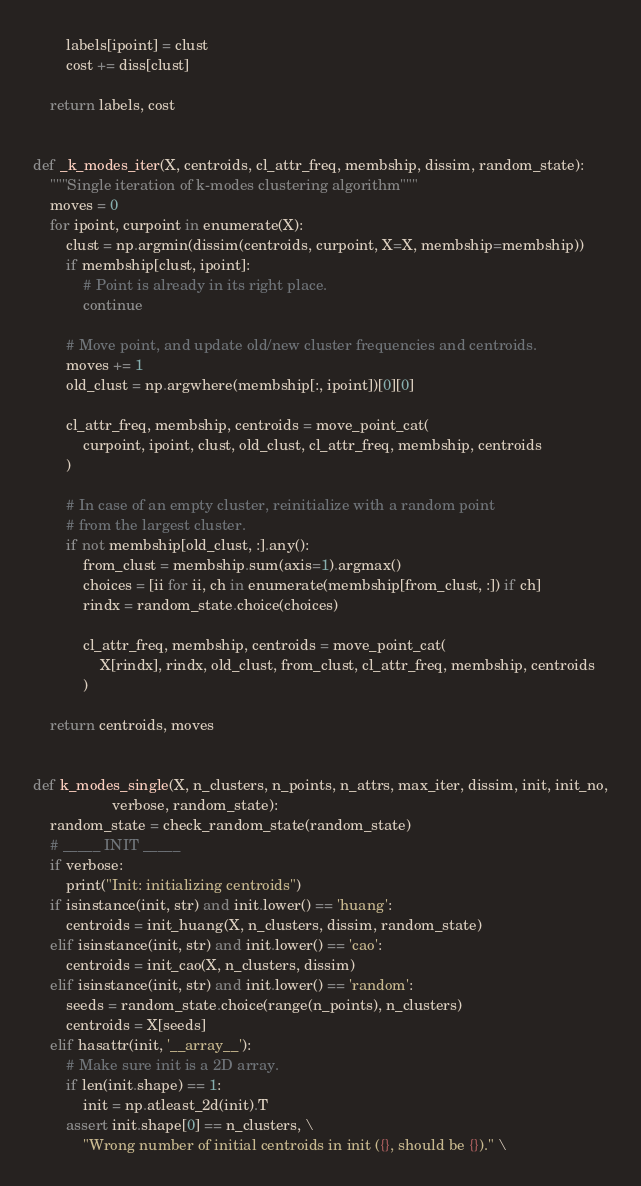<code> <loc_0><loc_0><loc_500><loc_500><_Python_>        labels[ipoint] = clust
        cost += diss[clust]

    return labels, cost


def _k_modes_iter(X, centroids, cl_attr_freq, membship, dissim, random_state):
    """Single iteration of k-modes clustering algorithm"""
    moves = 0
    for ipoint, curpoint in enumerate(X):
        clust = np.argmin(dissim(centroids, curpoint, X=X, membship=membship))
        if membship[clust, ipoint]:
            # Point is already in its right place.
            continue

        # Move point, and update old/new cluster frequencies and centroids.
        moves += 1
        old_clust = np.argwhere(membship[:, ipoint])[0][0]

        cl_attr_freq, membship, centroids = move_point_cat(
            curpoint, ipoint, clust, old_clust, cl_attr_freq, membship, centroids
        )

        # In case of an empty cluster, reinitialize with a random point
        # from the largest cluster.
        if not membship[old_clust, :].any():
            from_clust = membship.sum(axis=1).argmax()
            choices = [ii for ii, ch in enumerate(membship[from_clust, :]) if ch]
            rindx = random_state.choice(choices)

            cl_attr_freq, membship, centroids = move_point_cat(
                X[rindx], rindx, old_clust, from_clust, cl_attr_freq, membship, centroids
            )

    return centroids, moves


def k_modes_single(X, n_clusters, n_points, n_attrs, max_iter, dissim, init, init_no,
                   verbose, random_state):
    random_state = check_random_state(random_state)
    # _____ INIT _____
    if verbose:
        print("Init: initializing centroids")
    if isinstance(init, str) and init.lower() == 'huang':
        centroids = init_huang(X, n_clusters, dissim, random_state)
    elif isinstance(init, str) and init.lower() == 'cao':
        centroids = init_cao(X, n_clusters, dissim)
    elif isinstance(init, str) and init.lower() == 'random':
        seeds = random_state.choice(range(n_points), n_clusters)
        centroids = X[seeds]
    elif hasattr(init, '__array__'):
        # Make sure init is a 2D array.
        if len(init.shape) == 1:
            init = np.atleast_2d(init).T
        assert init.shape[0] == n_clusters, \
            "Wrong number of initial centroids in init ({}, should be {})." \</code> 